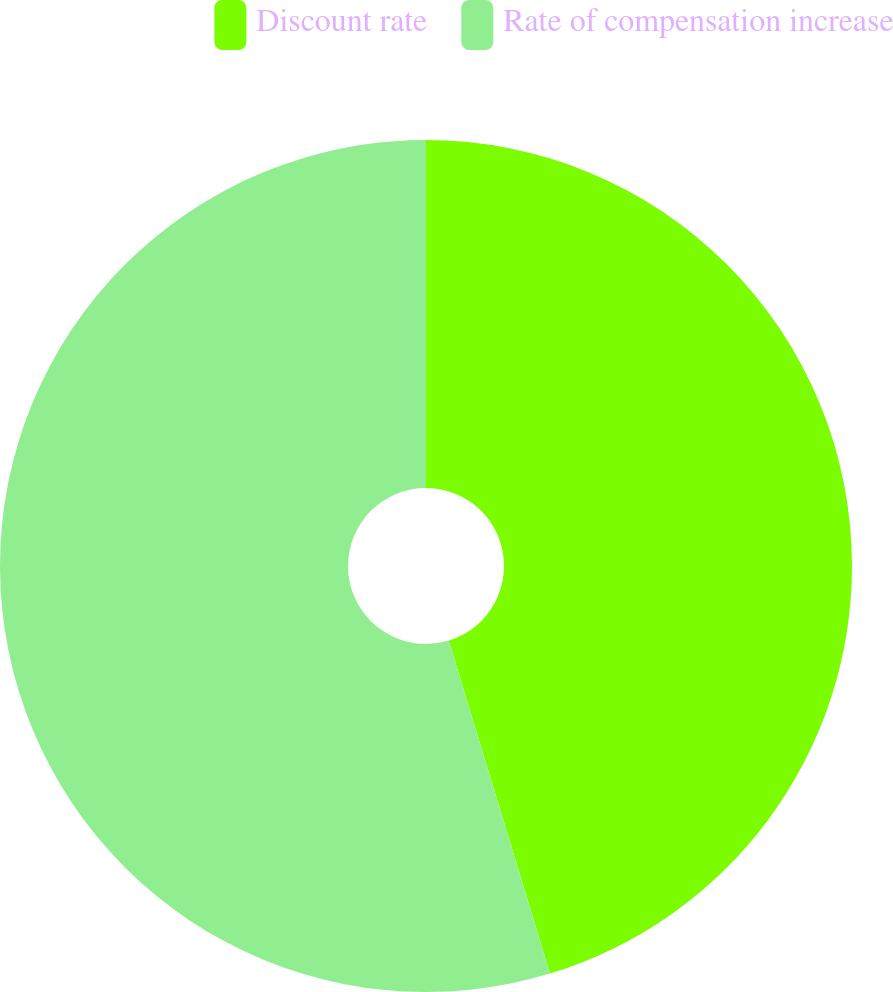<chart> <loc_0><loc_0><loc_500><loc_500><pie_chart><fcel>Discount rate<fcel>Rate of compensation increase<nl><fcel>45.3%<fcel>54.7%<nl></chart> 